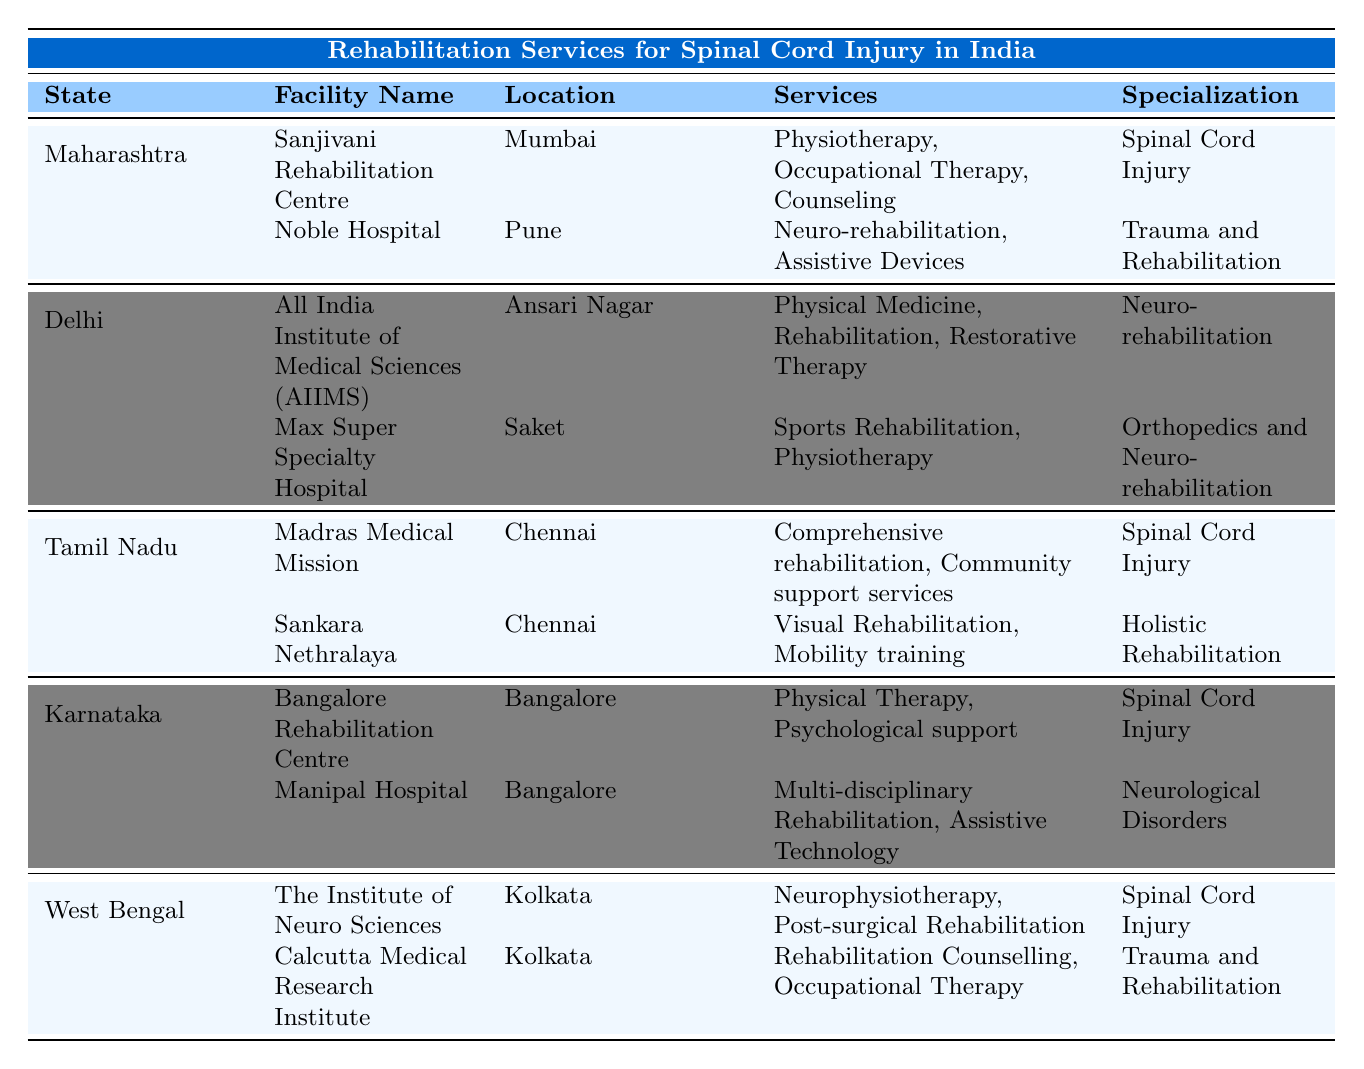What are the services provided by Madras Medical Mission? According to the table, the Madras Medical Mission provides "Comprehensive rehabilitation" and "Community support services" in Chennai, specializing in spinal cord injury.
Answer: Comprehensive rehabilitation, Community support services Which facility in Karnataka provides psychological support? The table shows that the Bangalore Rehabilitation Centre in Bangalore offers "Physical Therapy" and "Psychological support" and specializes in spinal cord injury.
Answer: Bangalore Rehabilitation Centre Is there a facility in Delhi specializing in neuro-rehabilitation? Yes, the All India Institute of Medical Sciences (AIIMS) in Ansari Nagar specializes in neuro-rehabilitation, as per the table data.
Answer: Yes How many facilities in Maharashtra focus on spinal cord injury? In Maharashtra, there is one facility, the Sanjivani Rehabilitation Centre, specializing in spinal cord injury according to the table; therefore, the total is one.
Answer: 1 Which state has the most facilities listed in the table? By reviewing the table, all states mentioned have two facilities each; therefore, no state has more than others.
Answer: None What services are provided by the Institute of Neuro Sciences in West Bengal? The table states that The Institute of Neuro Sciences in Kolkata provides "Neurophysiotherapy" and "Post-surgical Rehabilitation," specializing in spinal cord injury.
Answer: Neurophysiotherapy, Post-surgical Rehabilitation Does every facility listed in Tamil Nadu specialize in spinal cord injuries? No, the Sankara Nethralaya in Chennai specializes in holistic rehabilitation, so not every facility focuses on spinal cord injuries.
Answer: No Which hospitals provide assistive devices in Maharashtra? The table shows that Noble Hospital in Pune, among others, offers "Assistive Devices" as part of its services, specializing in trauma and rehabilitation.
Answer: Noble Hospital 